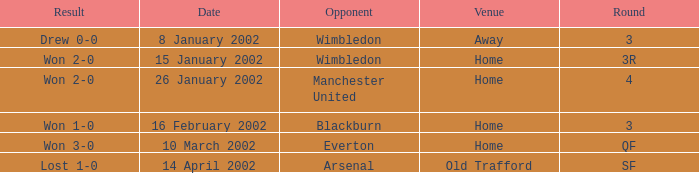What is the Date with an Opponent with wimbledon, and a Result of drew 0-0? 8 January 2002. 